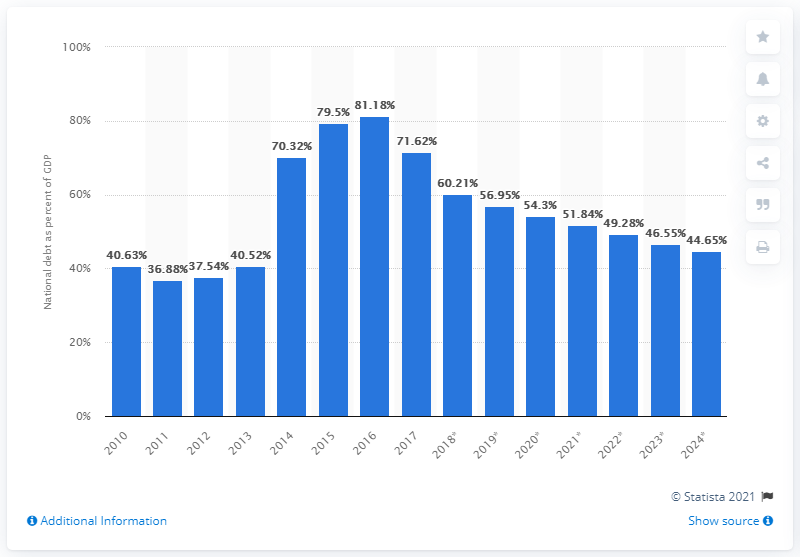Draw attention to some important aspects in this diagram. In 2018, Ukraine's national debt accounted for approximately 60.21% of the country's GDP, a significant increase from the previous year. 